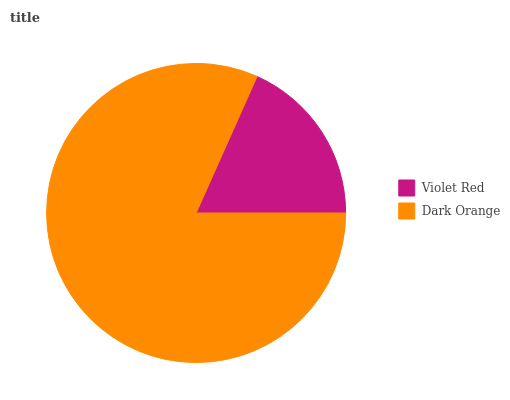Is Violet Red the minimum?
Answer yes or no. Yes. Is Dark Orange the maximum?
Answer yes or no. Yes. Is Dark Orange the minimum?
Answer yes or no. No. Is Dark Orange greater than Violet Red?
Answer yes or no. Yes. Is Violet Red less than Dark Orange?
Answer yes or no. Yes. Is Violet Red greater than Dark Orange?
Answer yes or no. No. Is Dark Orange less than Violet Red?
Answer yes or no. No. Is Dark Orange the high median?
Answer yes or no. Yes. Is Violet Red the low median?
Answer yes or no. Yes. Is Violet Red the high median?
Answer yes or no. No. Is Dark Orange the low median?
Answer yes or no. No. 